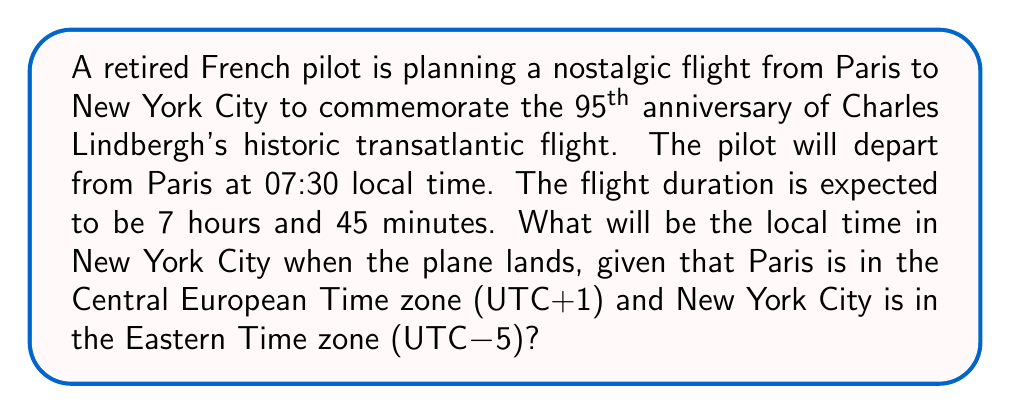Show me your answer to this math problem. Let's approach this problem step-by-step:

1. Identify the time zones:
   - Paris: UTC+1
   - New York City: UTC-5
   - Time difference: 6 hours

2. Convert Paris departure time to UTC:
   $07:30 \text{ Paris time} - 1 \text{ hour} = 06:30 \text{ UTC}$

3. Add flight duration to UTC departure time:
   $06:30 \text{ UTC} + 7 \text{ hours and } 45 \text{ minutes} = 14:15 \text{ UTC}$

4. Convert UTC arrival time to New York City local time:
   $14:15 \text{ UTC} - 5 \text{ hours} = 09:15 \text{ New York City time}$

5. Verify the calculation:
   $$\begin{align}
   \text{Paris departure} &: 07:30 \text{ (local)} \\
   \text{Flight duration} &: +7:45 \\
   \text{Time zone change} &: -6:00 \\
   \text{New York arrival} &: 09:15 \text{ (local)}
   \end{align}$$
Answer: 09:15 